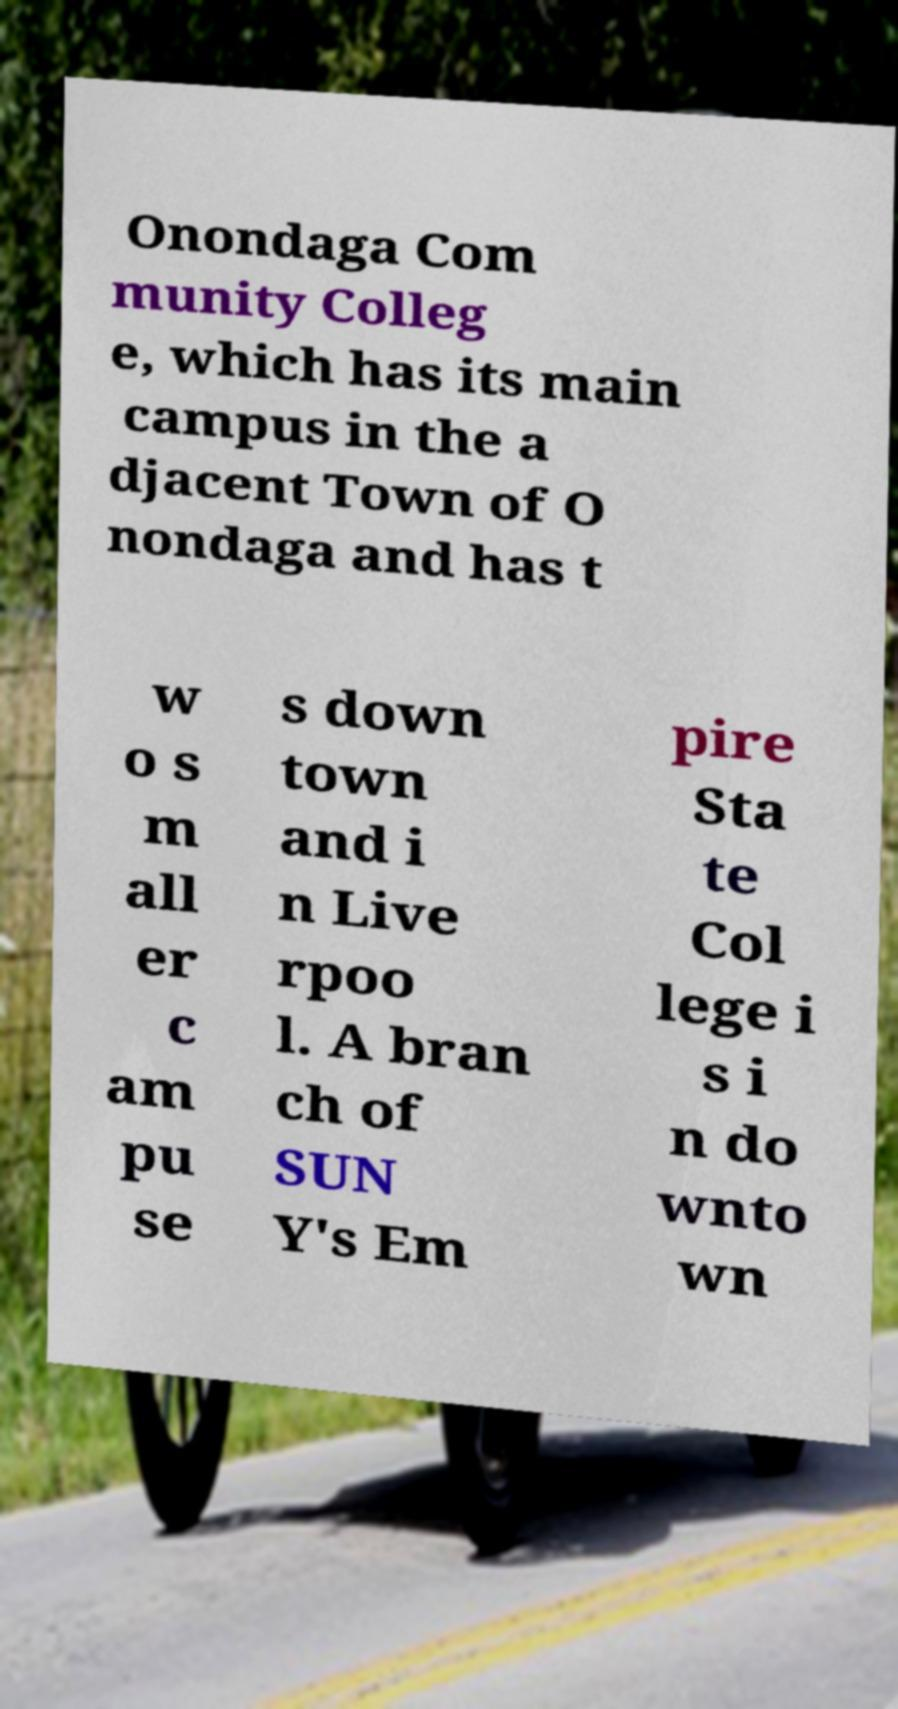Please read and relay the text visible in this image. What does it say? Onondaga Com munity Colleg e, which has its main campus in the a djacent Town of O nondaga and has t w o s m all er c am pu se s down town and i n Live rpoo l. A bran ch of SUN Y's Em pire Sta te Col lege i s i n do wnto wn 